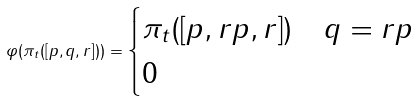<formula> <loc_0><loc_0><loc_500><loc_500>\varphi ( \pi _ { t } ( [ p , q , r ] ) ) = \begin{cases} \pi _ { t } ( [ p , r p , r ] ) & q = r p \\ 0 & \end{cases}</formula> 